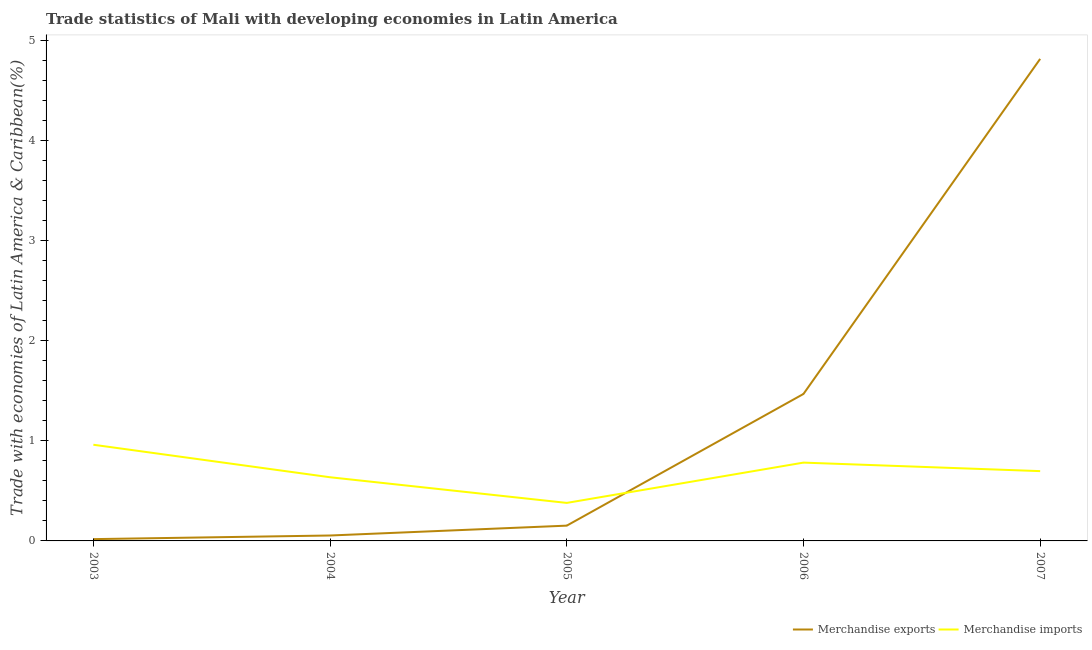Does the line corresponding to merchandise imports intersect with the line corresponding to merchandise exports?
Provide a short and direct response. Yes. Is the number of lines equal to the number of legend labels?
Your answer should be compact. Yes. What is the merchandise imports in 2003?
Keep it short and to the point. 0.96. Across all years, what is the maximum merchandise imports?
Provide a succinct answer. 0.96. Across all years, what is the minimum merchandise exports?
Keep it short and to the point. 0.02. In which year was the merchandise exports maximum?
Your response must be concise. 2007. What is the total merchandise exports in the graph?
Give a very brief answer. 6.51. What is the difference between the merchandise imports in 2005 and that in 2007?
Offer a terse response. -0.32. What is the difference between the merchandise imports in 2006 and the merchandise exports in 2005?
Offer a terse response. 0.63. What is the average merchandise imports per year?
Offer a terse response. 0.69. In the year 2005, what is the difference between the merchandise imports and merchandise exports?
Keep it short and to the point. 0.23. What is the ratio of the merchandise imports in 2005 to that in 2007?
Your answer should be very brief. 0.54. Is the difference between the merchandise exports in 2003 and 2004 greater than the difference between the merchandise imports in 2003 and 2004?
Keep it short and to the point. No. What is the difference between the highest and the second highest merchandise exports?
Give a very brief answer. 3.35. What is the difference between the highest and the lowest merchandise exports?
Make the answer very short. 4.8. Is the sum of the merchandise imports in 2003 and 2005 greater than the maximum merchandise exports across all years?
Your response must be concise. No. Does the merchandise imports monotonically increase over the years?
Give a very brief answer. No. Is the merchandise exports strictly greater than the merchandise imports over the years?
Provide a short and direct response. No. How many lines are there?
Provide a succinct answer. 2. What is the difference between two consecutive major ticks on the Y-axis?
Provide a short and direct response. 1. Are the values on the major ticks of Y-axis written in scientific E-notation?
Your answer should be compact. No. Does the graph contain grids?
Provide a short and direct response. No. Where does the legend appear in the graph?
Offer a terse response. Bottom right. How are the legend labels stacked?
Your answer should be very brief. Horizontal. What is the title of the graph?
Offer a terse response. Trade statistics of Mali with developing economies in Latin America. What is the label or title of the Y-axis?
Give a very brief answer. Trade with economies of Latin America & Caribbean(%). What is the Trade with economies of Latin America & Caribbean(%) of Merchandise exports in 2003?
Your response must be concise. 0.02. What is the Trade with economies of Latin America & Caribbean(%) of Merchandise imports in 2003?
Your answer should be very brief. 0.96. What is the Trade with economies of Latin America & Caribbean(%) in Merchandise exports in 2004?
Make the answer very short. 0.05. What is the Trade with economies of Latin America & Caribbean(%) in Merchandise imports in 2004?
Give a very brief answer. 0.64. What is the Trade with economies of Latin America & Caribbean(%) in Merchandise exports in 2005?
Provide a short and direct response. 0.15. What is the Trade with economies of Latin America & Caribbean(%) in Merchandise imports in 2005?
Provide a succinct answer. 0.38. What is the Trade with economies of Latin America & Caribbean(%) of Merchandise exports in 2006?
Offer a terse response. 1.47. What is the Trade with economies of Latin America & Caribbean(%) of Merchandise imports in 2006?
Offer a terse response. 0.78. What is the Trade with economies of Latin America & Caribbean(%) of Merchandise exports in 2007?
Ensure brevity in your answer.  4.82. What is the Trade with economies of Latin America & Caribbean(%) in Merchandise imports in 2007?
Your answer should be very brief. 0.7. Across all years, what is the maximum Trade with economies of Latin America & Caribbean(%) of Merchandise exports?
Keep it short and to the point. 4.82. Across all years, what is the maximum Trade with economies of Latin America & Caribbean(%) in Merchandise imports?
Keep it short and to the point. 0.96. Across all years, what is the minimum Trade with economies of Latin America & Caribbean(%) of Merchandise exports?
Your answer should be very brief. 0.02. Across all years, what is the minimum Trade with economies of Latin America & Caribbean(%) of Merchandise imports?
Provide a short and direct response. 0.38. What is the total Trade with economies of Latin America & Caribbean(%) of Merchandise exports in the graph?
Make the answer very short. 6.51. What is the total Trade with economies of Latin America & Caribbean(%) of Merchandise imports in the graph?
Your response must be concise. 3.46. What is the difference between the Trade with economies of Latin America & Caribbean(%) in Merchandise exports in 2003 and that in 2004?
Make the answer very short. -0.04. What is the difference between the Trade with economies of Latin America & Caribbean(%) in Merchandise imports in 2003 and that in 2004?
Offer a very short reply. 0.32. What is the difference between the Trade with economies of Latin America & Caribbean(%) in Merchandise exports in 2003 and that in 2005?
Your answer should be compact. -0.13. What is the difference between the Trade with economies of Latin America & Caribbean(%) of Merchandise imports in 2003 and that in 2005?
Offer a terse response. 0.58. What is the difference between the Trade with economies of Latin America & Caribbean(%) in Merchandise exports in 2003 and that in 2006?
Your response must be concise. -1.45. What is the difference between the Trade with economies of Latin America & Caribbean(%) of Merchandise imports in 2003 and that in 2006?
Give a very brief answer. 0.18. What is the difference between the Trade with economies of Latin America & Caribbean(%) of Merchandise exports in 2003 and that in 2007?
Offer a very short reply. -4.8. What is the difference between the Trade with economies of Latin America & Caribbean(%) in Merchandise imports in 2003 and that in 2007?
Give a very brief answer. 0.26. What is the difference between the Trade with economies of Latin America & Caribbean(%) of Merchandise exports in 2004 and that in 2005?
Your response must be concise. -0.1. What is the difference between the Trade with economies of Latin America & Caribbean(%) of Merchandise imports in 2004 and that in 2005?
Offer a terse response. 0.26. What is the difference between the Trade with economies of Latin America & Caribbean(%) in Merchandise exports in 2004 and that in 2006?
Make the answer very short. -1.41. What is the difference between the Trade with economies of Latin America & Caribbean(%) in Merchandise imports in 2004 and that in 2006?
Your answer should be very brief. -0.15. What is the difference between the Trade with economies of Latin America & Caribbean(%) in Merchandise exports in 2004 and that in 2007?
Ensure brevity in your answer.  -4.76. What is the difference between the Trade with economies of Latin America & Caribbean(%) of Merchandise imports in 2004 and that in 2007?
Your answer should be compact. -0.06. What is the difference between the Trade with economies of Latin America & Caribbean(%) of Merchandise exports in 2005 and that in 2006?
Your answer should be compact. -1.32. What is the difference between the Trade with economies of Latin America & Caribbean(%) in Merchandise imports in 2005 and that in 2006?
Provide a short and direct response. -0.4. What is the difference between the Trade with economies of Latin America & Caribbean(%) of Merchandise exports in 2005 and that in 2007?
Your response must be concise. -4.66. What is the difference between the Trade with economies of Latin America & Caribbean(%) in Merchandise imports in 2005 and that in 2007?
Ensure brevity in your answer.  -0.32. What is the difference between the Trade with economies of Latin America & Caribbean(%) in Merchandise exports in 2006 and that in 2007?
Ensure brevity in your answer.  -3.35. What is the difference between the Trade with economies of Latin America & Caribbean(%) in Merchandise imports in 2006 and that in 2007?
Give a very brief answer. 0.09. What is the difference between the Trade with economies of Latin America & Caribbean(%) of Merchandise exports in 2003 and the Trade with economies of Latin America & Caribbean(%) of Merchandise imports in 2004?
Your response must be concise. -0.62. What is the difference between the Trade with economies of Latin America & Caribbean(%) of Merchandise exports in 2003 and the Trade with economies of Latin America & Caribbean(%) of Merchandise imports in 2005?
Provide a succinct answer. -0.36. What is the difference between the Trade with economies of Latin America & Caribbean(%) in Merchandise exports in 2003 and the Trade with economies of Latin America & Caribbean(%) in Merchandise imports in 2006?
Ensure brevity in your answer.  -0.76. What is the difference between the Trade with economies of Latin America & Caribbean(%) in Merchandise exports in 2003 and the Trade with economies of Latin America & Caribbean(%) in Merchandise imports in 2007?
Offer a terse response. -0.68. What is the difference between the Trade with economies of Latin America & Caribbean(%) of Merchandise exports in 2004 and the Trade with economies of Latin America & Caribbean(%) of Merchandise imports in 2005?
Offer a terse response. -0.33. What is the difference between the Trade with economies of Latin America & Caribbean(%) of Merchandise exports in 2004 and the Trade with economies of Latin America & Caribbean(%) of Merchandise imports in 2006?
Make the answer very short. -0.73. What is the difference between the Trade with economies of Latin America & Caribbean(%) in Merchandise exports in 2004 and the Trade with economies of Latin America & Caribbean(%) in Merchandise imports in 2007?
Your answer should be compact. -0.64. What is the difference between the Trade with economies of Latin America & Caribbean(%) of Merchandise exports in 2005 and the Trade with economies of Latin America & Caribbean(%) of Merchandise imports in 2006?
Provide a succinct answer. -0.63. What is the difference between the Trade with economies of Latin America & Caribbean(%) in Merchandise exports in 2005 and the Trade with economies of Latin America & Caribbean(%) in Merchandise imports in 2007?
Make the answer very short. -0.54. What is the difference between the Trade with economies of Latin America & Caribbean(%) of Merchandise exports in 2006 and the Trade with economies of Latin America & Caribbean(%) of Merchandise imports in 2007?
Keep it short and to the point. 0.77. What is the average Trade with economies of Latin America & Caribbean(%) of Merchandise exports per year?
Your answer should be compact. 1.3. What is the average Trade with economies of Latin America & Caribbean(%) in Merchandise imports per year?
Give a very brief answer. 0.69. In the year 2003, what is the difference between the Trade with economies of Latin America & Caribbean(%) in Merchandise exports and Trade with economies of Latin America & Caribbean(%) in Merchandise imports?
Give a very brief answer. -0.94. In the year 2004, what is the difference between the Trade with economies of Latin America & Caribbean(%) in Merchandise exports and Trade with economies of Latin America & Caribbean(%) in Merchandise imports?
Your response must be concise. -0.58. In the year 2005, what is the difference between the Trade with economies of Latin America & Caribbean(%) of Merchandise exports and Trade with economies of Latin America & Caribbean(%) of Merchandise imports?
Your answer should be very brief. -0.23. In the year 2006, what is the difference between the Trade with economies of Latin America & Caribbean(%) of Merchandise exports and Trade with economies of Latin America & Caribbean(%) of Merchandise imports?
Offer a terse response. 0.69. In the year 2007, what is the difference between the Trade with economies of Latin America & Caribbean(%) of Merchandise exports and Trade with economies of Latin America & Caribbean(%) of Merchandise imports?
Make the answer very short. 4.12. What is the ratio of the Trade with economies of Latin America & Caribbean(%) of Merchandise exports in 2003 to that in 2004?
Your response must be concise. 0.33. What is the ratio of the Trade with economies of Latin America & Caribbean(%) in Merchandise imports in 2003 to that in 2004?
Provide a short and direct response. 1.51. What is the ratio of the Trade with economies of Latin America & Caribbean(%) in Merchandise exports in 2003 to that in 2005?
Keep it short and to the point. 0.12. What is the ratio of the Trade with economies of Latin America & Caribbean(%) of Merchandise imports in 2003 to that in 2005?
Your answer should be very brief. 2.53. What is the ratio of the Trade with economies of Latin America & Caribbean(%) of Merchandise exports in 2003 to that in 2006?
Ensure brevity in your answer.  0.01. What is the ratio of the Trade with economies of Latin America & Caribbean(%) of Merchandise imports in 2003 to that in 2006?
Ensure brevity in your answer.  1.23. What is the ratio of the Trade with economies of Latin America & Caribbean(%) of Merchandise exports in 2003 to that in 2007?
Provide a succinct answer. 0. What is the ratio of the Trade with economies of Latin America & Caribbean(%) in Merchandise imports in 2003 to that in 2007?
Keep it short and to the point. 1.38. What is the ratio of the Trade with economies of Latin America & Caribbean(%) of Merchandise exports in 2004 to that in 2005?
Offer a terse response. 0.35. What is the ratio of the Trade with economies of Latin America & Caribbean(%) in Merchandise imports in 2004 to that in 2005?
Offer a terse response. 1.67. What is the ratio of the Trade with economies of Latin America & Caribbean(%) of Merchandise exports in 2004 to that in 2006?
Ensure brevity in your answer.  0.04. What is the ratio of the Trade with economies of Latin America & Caribbean(%) in Merchandise imports in 2004 to that in 2006?
Offer a very short reply. 0.81. What is the ratio of the Trade with economies of Latin America & Caribbean(%) of Merchandise exports in 2004 to that in 2007?
Ensure brevity in your answer.  0.01. What is the ratio of the Trade with economies of Latin America & Caribbean(%) in Merchandise imports in 2004 to that in 2007?
Keep it short and to the point. 0.91. What is the ratio of the Trade with economies of Latin America & Caribbean(%) of Merchandise exports in 2005 to that in 2006?
Keep it short and to the point. 0.1. What is the ratio of the Trade with economies of Latin America & Caribbean(%) of Merchandise imports in 2005 to that in 2006?
Your response must be concise. 0.49. What is the ratio of the Trade with economies of Latin America & Caribbean(%) in Merchandise exports in 2005 to that in 2007?
Ensure brevity in your answer.  0.03. What is the ratio of the Trade with economies of Latin America & Caribbean(%) in Merchandise imports in 2005 to that in 2007?
Your answer should be very brief. 0.54. What is the ratio of the Trade with economies of Latin America & Caribbean(%) in Merchandise exports in 2006 to that in 2007?
Your answer should be very brief. 0.3. What is the ratio of the Trade with economies of Latin America & Caribbean(%) in Merchandise imports in 2006 to that in 2007?
Your answer should be compact. 1.12. What is the difference between the highest and the second highest Trade with economies of Latin America & Caribbean(%) in Merchandise exports?
Offer a very short reply. 3.35. What is the difference between the highest and the second highest Trade with economies of Latin America & Caribbean(%) in Merchandise imports?
Make the answer very short. 0.18. What is the difference between the highest and the lowest Trade with economies of Latin America & Caribbean(%) in Merchandise exports?
Offer a very short reply. 4.8. What is the difference between the highest and the lowest Trade with economies of Latin America & Caribbean(%) in Merchandise imports?
Offer a very short reply. 0.58. 